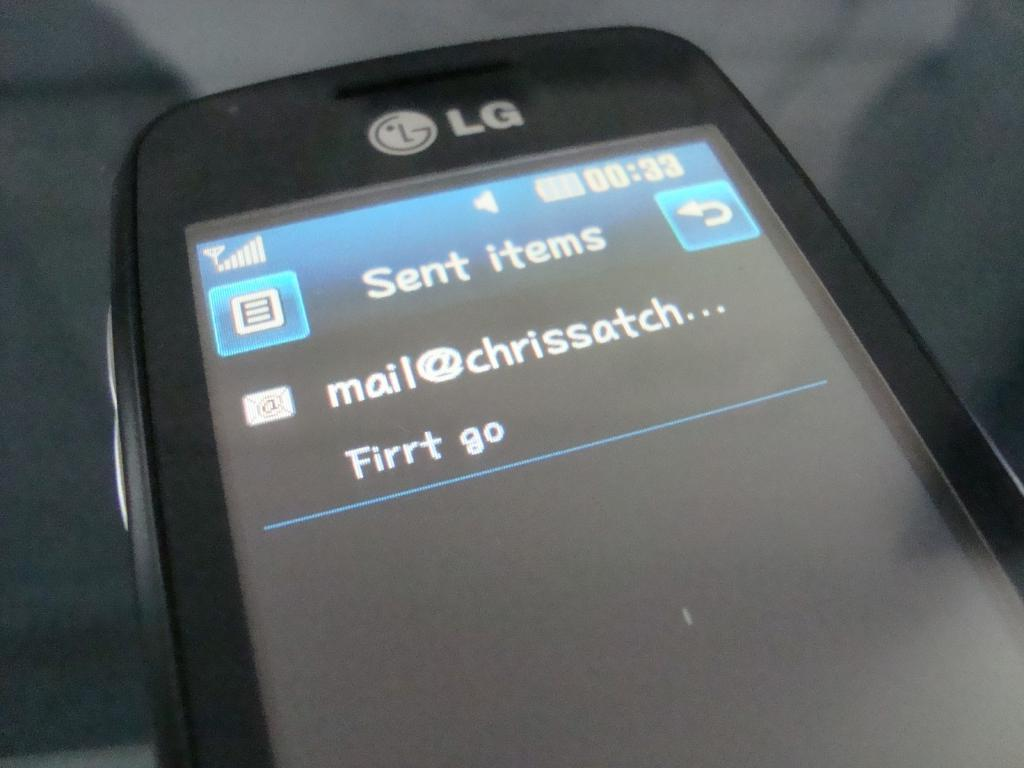<image>
Render a clear and concise summary of the photo. An LG cellphone is showing a sent message that says Firrt go. 